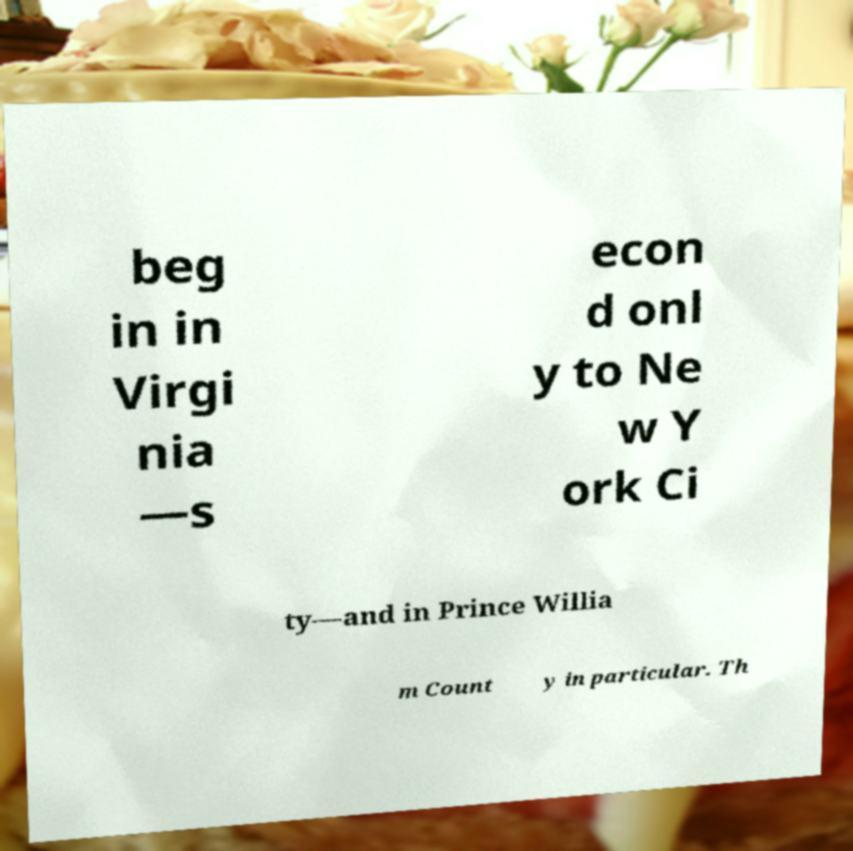I need the written content from this picture converted into text. Can you do that? beg in in Virgi nia —s econ d onl y to Ne w Y ork Ci ty—and in Prince Willia m Count y in particular. Th 